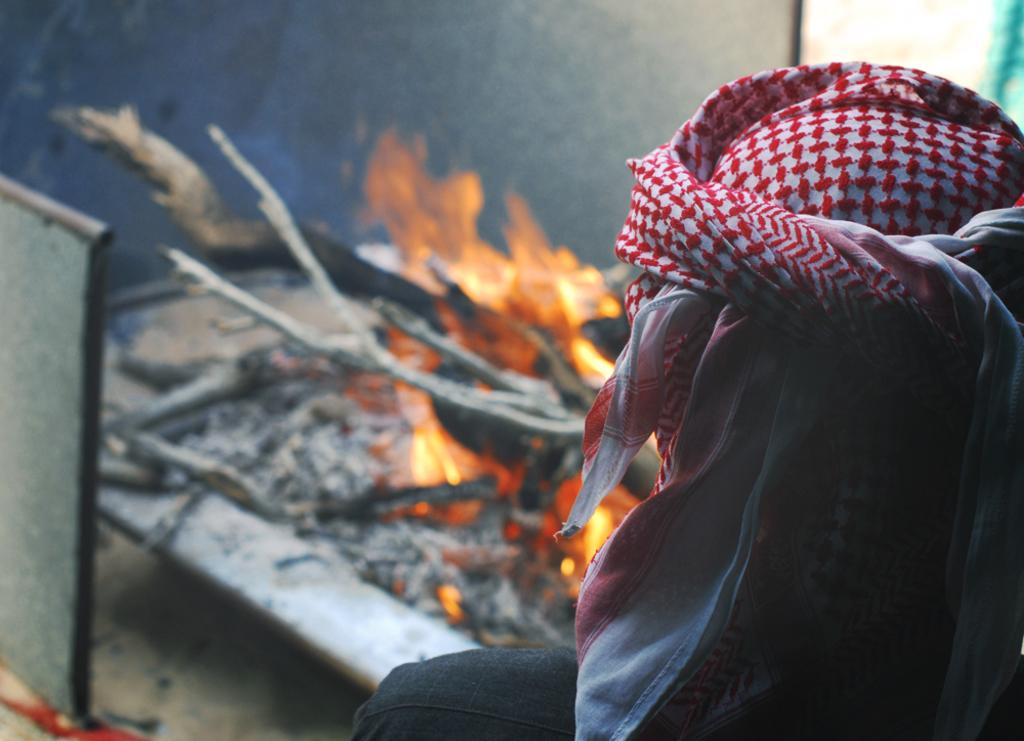Who or what is present in the image? There is a person in the image. What is the person wearing on their head? The person is wearing a hat. What can be seen in the middle of the image? There is a flame in the middle of the image. What type of whip is the person holding in the image? There is no whip present in the image; the person is not holding any object. 